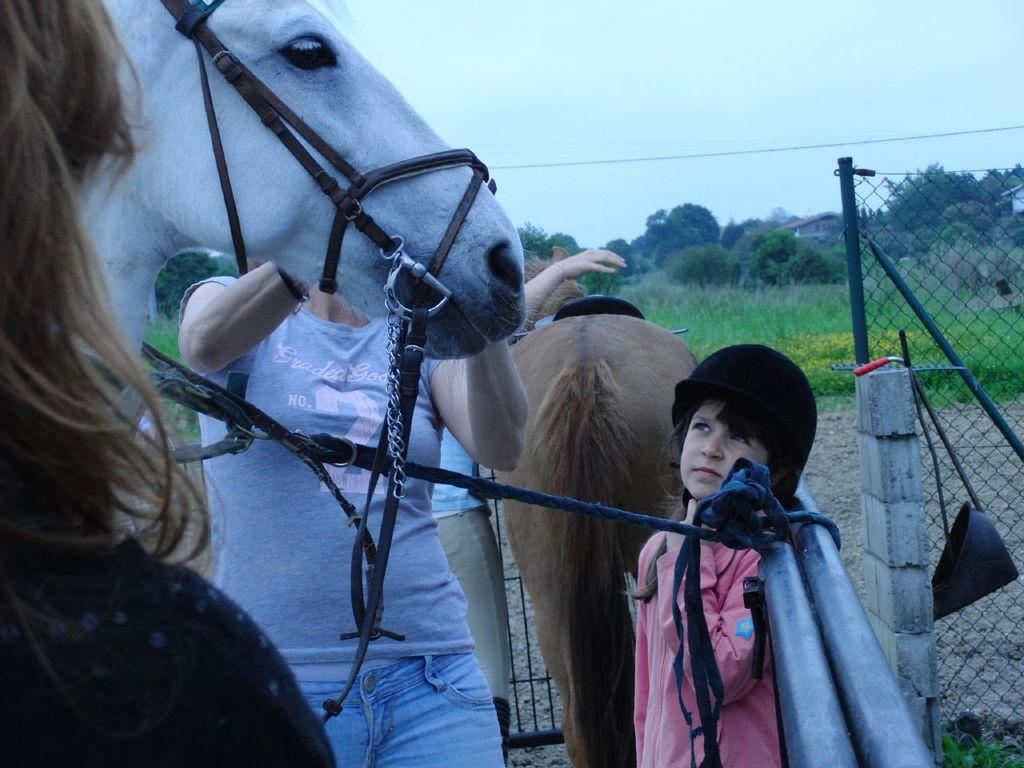What can be seen in the image? There are people standing and horses in the image. What is the rope attached to in the image? The rope is attached to a rod in the image. What type of barrier is present in the image? There is a fence in the image. What type of vegetation is visible in the background of the image? There is grass and trees in the background of the image. What else can be seen in the background of the image? There is a wire and the sky visible in the background of the image. What country is the trail located in, as seen in the image? There is no trail visible in the image, so it cannot be determined which country the trail might be located in. 